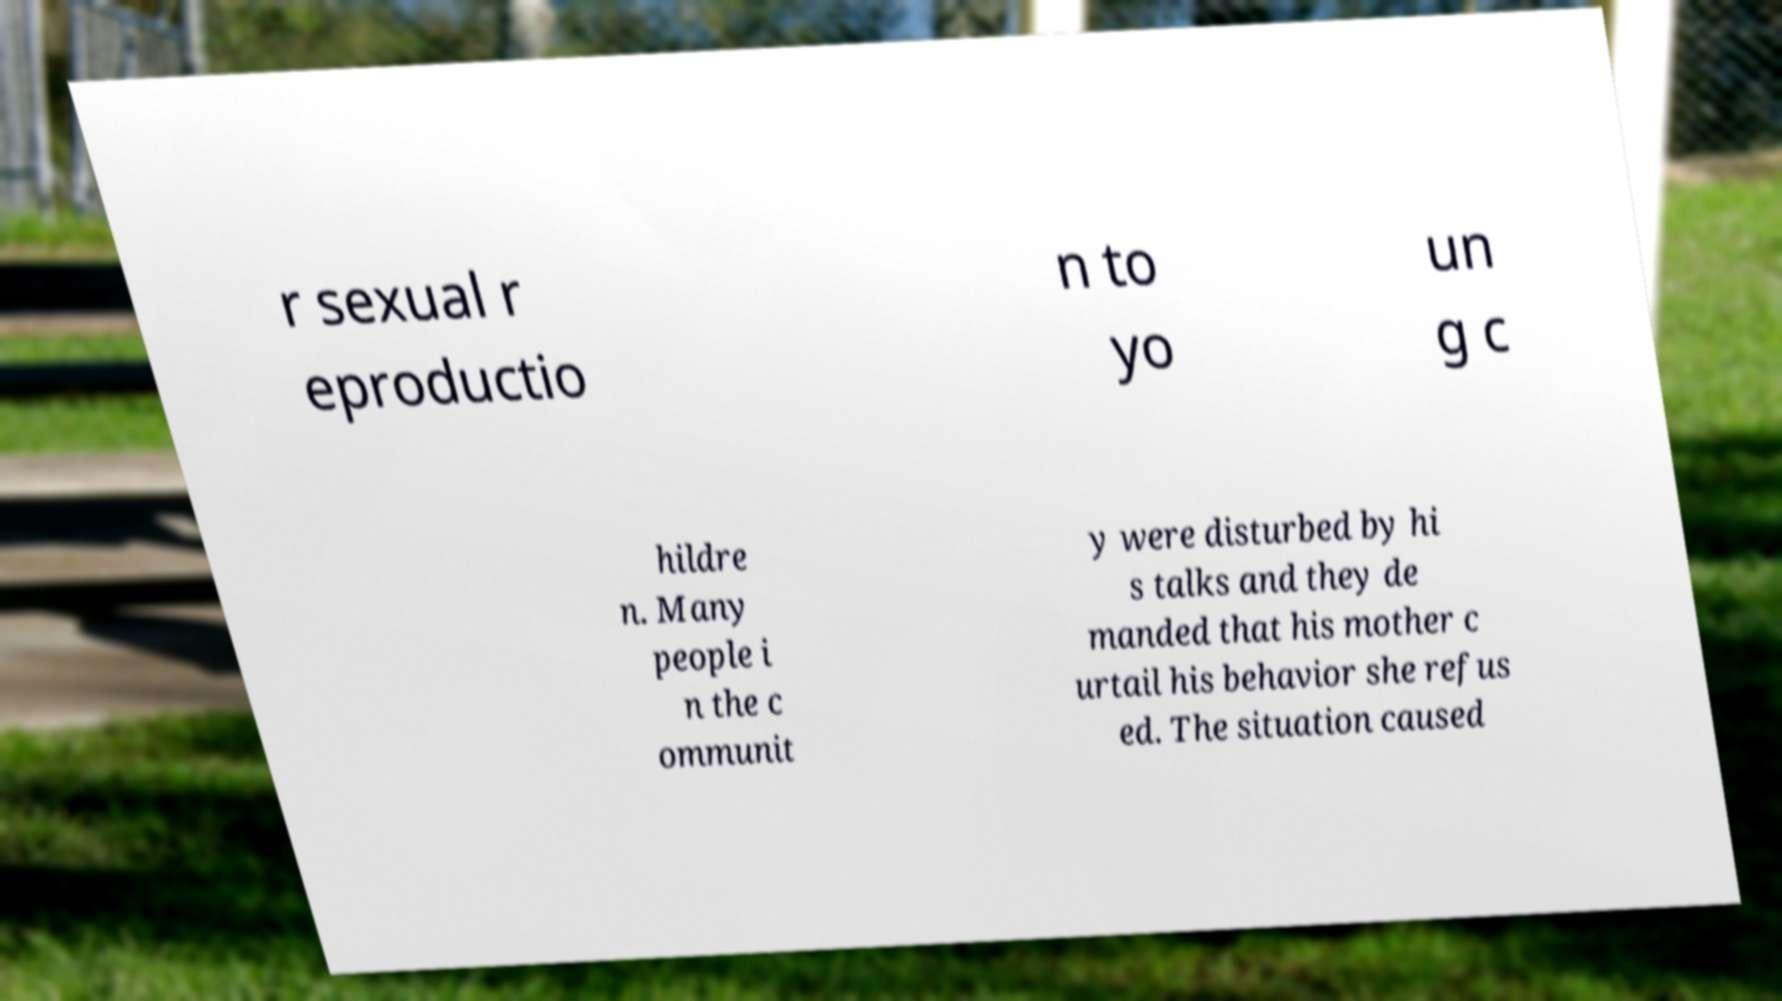Could you extract and type out the text from this image? r sexual r eproductio n to yo un g c hildre n. Many people i n the c ommunit y were disturbed by hi s talks and they de manded that his mother c urtail his behavior she refus ed. The situation caused 